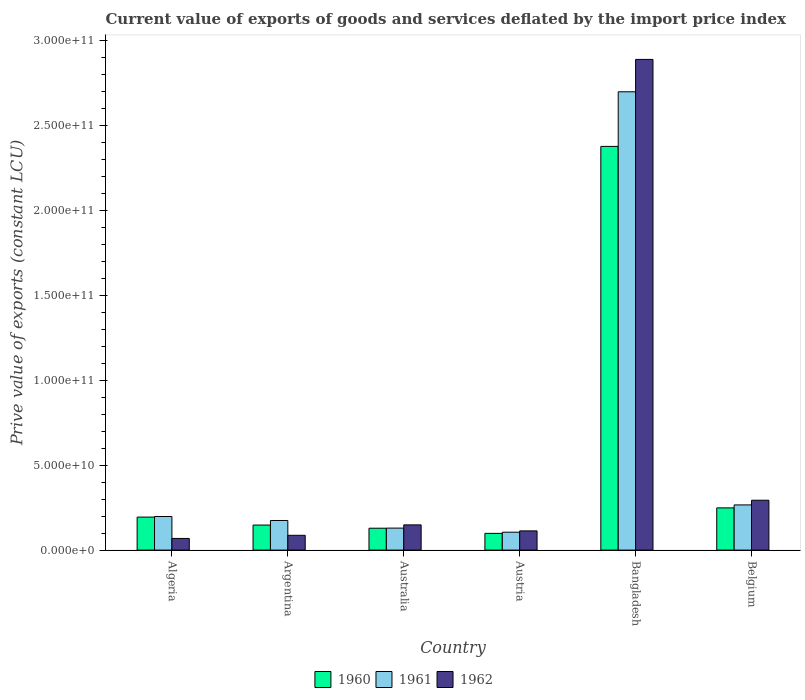How many bars are there on the 6th tick from the right?
Your response must be concise. 3. What is the prive value of exports in 1960 in Austria?
Offer a terse response. 9.86e+09. Across all countries, what is the maximum prive value of exports in 1961?
Provide a short and direct response. 2.70e+11. Across all countries, what is the minimum prive value of exports in 1961?
Offer a very short reply. 1.06e+1. In which country was the prive value of exports in 1960 minimum?
Offer a very short reply. Austria. What is the total prive value of exports in 1962 in the graph?
Your response must be concise. 3.60e+11. What is the difference between the prive value of exports in 1961 in Australia and that in Belgium?
Your answer should be compact. -1.37e+1. What is the difference between the prive value of exports in 1962 in Argentina and the prive value of exports in 1960 in Australia?
Make the answer very short. -4.17e+09. What is the average prive value of exports in 1962 per country?
Your answer should be very brief. 6.00e+1. What is the difference between the prive value of exports of/in 1962 and prive value of exports of/in 1961 in Belgium?
Ensure brevity in your answer.  2.76e+09. In how many countries, is the prive value of exports in 1960 greater than 180000000000 LCU?
Provide a short and direct response. 1. What is the ratio of the prive value of exports in 1961 in Algeria to that in Australia?
Your answer should be compact. 1.53. Is the prive value of exports in 1960 in Algeria less than that in Belgium?
Keep it short and to the point. Yes. What is the difference between the highest and the second highest prive value of exports in 1960?
Provide a succinct answer. 2.13e+11. What is the difference between the highest and the lowest prive value of exports in 1961?
Keep it short and to the point. 2.59e+11. Is the sum of the prive value of exports in 1960 in Algeria and Austria greater than the maximum prive value of exports in 1962 across all countries?
Make the answer very short. No. What does the 3rd bar from the left in Belgium represents?
Make the answer very short. 1962. What does the 1st bar from the right in Belgium represents?
Your answer should be very brief. 1962. Is it the case that in every country, the sum of the prive value of exports in 1962 and prive value of exports in 1961 is greater than the prive value of exports in 1960?
Your answer should be compact. Yes. How many bars are there?
Ensure brevity in your answer.  18. Are the values on the major ticks of Y-axis written in scientific E-notation?
Give a very brief answer. Yes. How are the legend labels stacked?
Provide a succinct answer. Horizontal. What is the title of the graph?
Provide a short and direct response. Current value of exports of goods and services deflated by the import price index. What is the label or title of the Y-axis?
Keep it short and to the point. Prive value of exports (constant LCU). What is the Prive value of exports (constant LCU) of 1960 in Algeria?
Keep it short and to the point. 1.94e+1. What is the Prive value of exports (constant LCU) in 1961 in Algeria?
Offer a terse response. 1.98e+1. What is the Prive value of exports (constant LCU) of 1962 in Algeria?
Offer a terse response. 6.86e+09. What is the Prive value of exports (constant LCU) in 1960 in Argentina?
Give a very brief answer. 1.48e+1. What is the Prive value of exports (constant LCU) in 1961 in Argentina?
Your response must be concise. 1.74e+1. What is the Prive value of exports (constant LCU) of 1962 in Argentina?
Provide a succinct answer. 8.72e+09. What is the Prive value of exports (constant LCU) of 1960 in Australia?
Ensure brevity in your answer.  1.29e+1. What is the Prive value of exports (constant LCU) of 1961 in Australia?
Your answer should be compact. 1.30e+1. What is the Prive value of exports (constant LCU) of 1962 in Australia?
Provide a short and direct response. 1.49e+1. What is the Prive value of exports (constant LCU) in 1960 in Austria?
Keep it short and to the point. 9.86e+09. What is the Prive value of exports (constant LCU) of 1961 in Austria?
Provide a short and direct response. 1.06e+1. What is the Prive value of exports (constant LCU) of 1962 in Austria?
Keep it short and to the point. 1.13e+1. What is the Prive value of exports (constant LCU) of 1960 in Bangladesh?
Offer a terse response. 2.38e+11. What is the Prive value of exports (constant LCU) of 1961 in Bangladesh?
Provide a short and direct response. 2.70e+11. What is the Prive value of exports (constant LCU) in 1962 in Bangladesh?
Offer a very short reply. 2.89e+11. What is the Prive value of exports (constant LCU) of 1960 in Belgium?
Give a very brief answer. 2.49e+1. What is the Prive value of exports (constant LCU) of 1961 in Belgium?
Give a very brief answer. 2.66e+1. What is the Prive value of exports (constant LCU) in 1962 in Belgium?
Your response must be concise. 2.94e+1. Across all countries, what is the maximum Prive value of exports (constant LCU) of 1960?
Your answer should be very brief. 2.38e+11. Across all countries, what is the maximum Prive value of exports (constant LCU) of 1961?
Your answer should be very brief. 2.70e+11. Across all countries, what is the maximum Prive value of exports (constant LCU) of 1962?
Your answer should be compact. 2.89e+11. Across all countries, what is the minimum Prive value of exports (constant LCU) of 1960?
Give a very brief answer. 9.86e+09. Across all countries, what is the minimum Prive value of exports (constant LCU) of 1961?
Offer a terse response. 1.06e+1. Across all countries, what is the minimum Prive value of exports (constant LCU) of 1962?
Your answer should be compact. 6.86e+09. What is the total Prive value of exports (constant LCU) in 1960 in the graph?
Ensure brevity in your answer.  3.20e+11. What is the total Prive value of exports (constant LCU) in 1961 in the graph?
Keep it short and to the point. 3.57e+11. What is the total Prive value of exports (constant LCU) of 1962 in the graph?
Keep it short and to the point. 3.60e+11. What is the difference between the Prive value of exports (constant LCU) in 1960 in Algeria and that in Argentina?
Your response must be concise. 4.69e+09. What is the difference between the Prive value of exports (constant LCU) in 1961 in Algeria and that in Argentina?
Offer a very short reply. 2.35e+09. What is the difference between the Prive value of exports (constant LCU) in 1962 in Algeria and that in Argentina?
Make the answer very short. -1.85e+09. What is the difference between the Prive value of exports (constant LCU) in 1960 in Algeria and that in Australia?
Your response must be concise. 6.55e+09. What is the difference between the Prive value of exports (constant LCU) of 1961 in Algeria and that in Australia?
Keep it short and to the point. 6.83e+09. What is the difference between the Prive value of exports (constant LCU) in 1962 in Algeria and that in Australia?
Offer a very short reply. -7.99e+09. What is the difference between the Prive value of exports (constant LCU) of 1960 in Algeria and that in Austria?
Make the answer very short. 9.59e+09. What is the difference between the Prive value of exports (constant LCU) in 1961 in Algeria and that in Austria?
Your answer should be compact. 9.23e+09. What is the difference between the Prive value of exports (constant LCU) in 1962 in Algeria and that in Austria?
Offer a very short reply. -4.45e+09. What is the difference between the Prive value of exports (constant LCU) in 1960 in Algeria and that in Bangladesh?
Your answer should be compact. -2.18e+11. What is the difference between the Prive value of exports (constant LCU) of 1961 in Algeria and that in Bangladesh?
Provide a succinct answer. -2.50e+11. What is the difference between the Prive value of exports (constant LCU) of 1962 in Algeria and that in Bangladesh?
Give a very brief answer. -2.82e+11. What is the difference between the Prive value of exports (constant LCU) in 1960 in Algeria and that in Belgium?
Ensure brevity in your answer.  -5.42e+09. What is the difference between the Prive value of exports (constant LCU) in 1961 in Algeria and that in Belgium?
Give a very brief answer. -6.83e+09. What is the difference between the Prive value of exports (constant LCU) of 1962 in Algeria and that in Belgium?
Your response must be concise. -2.25e+1. What is the difference between the Prive value of exports (constant LCU) in 1960 in Argentina and that in Australia?
Make the answer very short. 1.87e+09. What is the difference between the Prive value of exports (constant LCU) in 1961 in Argentina and that in Australia?
Give a very brief answer. 4.48e+09. What is the difference between the Prive value of exports (constant LCU) in 1962 in Argentina and that in Australia?
Make the answer very short. -6.14e+09. What is the difference between the Prive value of exports (constant LCU) in 1960 in Argentina and that in Austria?
Your response must be concise. 4.90e+09. What is the difference between the Prive value of exports (constant LCU) of 1961 in Argentina and that in Austria?
Your answer should be compact. 6.89e+09. What is the difference between the Prive value of exports (constant LCU) of 1962 in Argentina and that in Austria?
Keep it short and to the point. -2.60e+09. What is the difference between the Prive value of exports (constant LCU) of 1960 in Argentina and that in Bangladesh?
Offer a terse response. -2.23e+11. What is the difference between the Prive value of exports (constant LCU) in 1961 in Argentina and that in Bangladesh?
Keep it short and to the point. -2.53e+11. What is the difference between the Prive value of exports (constant LCU) in 1962 in Argentina and that in Bangladesh?
Offer a terse response. -2.80e+11. What is the difference between the Prive value of exports (constant LCU) of 1960 in Argentina and that in Belgium?
Keep it short and to the point. -1.01e+1. What is the difference between the Prive value of exports (constant LCU) in 1961 in Argentina and that in Belgium?
Provide a succinct answer. -9.17e+09. What is the difference between the Prive value of exports (constant LCU) in 1962 in Argentina and that in Belgium?
Keep it short and to the point. -2.07e+1. What is the difference between the Prive value of exports (constant LCU) of 1960 in Australia and that in Austria?
Give a very brief answer. 3.04e+09. What is the difference between the Prive value of exports (constant LCU) in 1961 in Australia and that in Austria?
Keep it short and to the point. 2.41e+09. What is the difference between the Prive value of exports (constant LCU) of 1962 in Australia and that in Austria?
Provide a short and direct response. 3.54e+09. What is the difference between the Prive value of exports (constant LCU) of 1960 in Australia and that in Bangladesh?
Offer a very short reply. -2.25e+11. What is the difference between the Prive value of exports (constant LCU) in 1961 in Australia and that in Bangladesh?
Keep it short and to the point. -2.57e+11. What is the difference between the Prive value of exports (constant LCU) of 1962 in Australia and that in Bangladesh?
Offer a terse response. -2.74e+11. What is the difference between the Prive value of exports (constant LCU) in 1960 in Australia and that in Belgium?
Your response must be concise. -1.20e+1. What is the difference between the Prive value of exports (constant LCU) of 1961 in Australia and that in Belgium?
Your answer should be very brief. -1.37e+1. What is the difference between the Prive value of exports (constant LCU) of 1962 in Australia and that in Belgium?
Provide a succinct answer. -1.45e+1. What is the difference between the Prive value of exports (constant LCU) of 1960 in Austria and that in Bangladesh?
Give a very brief answer. -2.28e+11. What is the difference between the Prive value of exports (constant LCU) in 1961 in Austria and that in Bangladesh?
Offer a very short reply. -2.59e+11. What is the difference between the Prive value of exports (constant LCU) of 1962 in Austria and that in Bangladesh?
Your answer should be compact. -2.78e+11. What is the difference between the Prive value of exports (constant LCU) in 1960 in Austria and that in Belgium?
Give a very brief answer. -1.50e+1. What is the difference between the Prive value of exports (constant LCU) in 1961 in Austria and that in Belgium?
Give a very brief answer. -1.61e+1. What is the difference between the Prive value of exports (constant LCU) in 1962 in Austria and that in Belgium?
Your answer should be very brief. -1.81e+1. What is the difference between the Prive value of exports (constant LCU) of 1960 in Bangladesh and that in Belgium?
Give a very brief answer. 2.13e+11. What is the difference between the Prive value of exports (constant LCU) of 1961 in Bangladesh and that in Belgium?
Offer a terse response. 2.43e+11. What is the difference between the Prive value of exports (constant LCU) in 1962 in Bangladesh and that in Belgium?
Your response must be concise. 2.60e+11. What is the difference between the Prive value of exports (constant LCU) of 1960 in Algeria and the Prive value of exports (constant LCU) of 1961 in Argentina?
Give a very brief answer. 2.01e+09. What is the difference between the Prive value of exports (constant LCU) of 1960 in Algeria and the Prive value of exports (constant LCU) of 1962 in Argentina?
Provide a succinct answer. 1.07e+1. What is the difference between the Prive value of exports (constant LCU) of 1961 in Algeria and the Prive value of exports (constant LCU) of 1962 in Argentina?
Keep it short and to the point. 1.11e+1. What is the difference between the Prive value of exports (constant LCU) of 1960 in Algeria and the Prive value of exports (constant LCU) of 1961 in Australia?
Provide a short and direct response. 6.49e+09. What is the difference between the Prive value of exports (constant LCU) in 1960 in Algeria and the Prive value of exports (constant LCU) in 1962 in Australia?
Your answer should be very brief. 4.59e+09. What is the difference between the Prive value of exports (constant LCU) of 1961 in Algeria and the Prive value of exports (constant LCU) of 1962 in Australia?
Provide a short and direct response. 4.93e+09. What is the difference between the Prive value of exports (constant LCU) in 1960 in Algeria and the Prive value of exports (constant LCU) in 1961 in Austria?
Your response must be concise. 8.89e+09. What is the difference between the Prive value of exports (constant LCU) in 1960 in Algeria and the Prive value of exports (constant LCU) in 1962 in Austria?
Keep it short and to the point. 8.13e+09. What is the difference between the Prive value of exports (constant LCU) in 1961 in Algeria and the Prive value of exports (constant LCU) in 1962 in Austria?
Keep it short and to the point. 8.47e+09. What is the difference between the Prive value of exports (constant LCU) in 1960 in Algeria and the Prive value of exports (constant LCU) in 1961 in Bangladesh?
Your response must be concise. -2.51e+11. What is the difference between the Prive value of exports (constant LCU) in 1960 in Algeria and the Prive value of exports (constant LCU) in 1962 in Bangladesh?
Make the answer very short. -2.70e+11. What is the difference between the Prive value of exports (constant LCU) of 1961 in Algeria and the Prive value of exports (constant LCU) of 1962 in Bangladesh?
Offer a very short reply. -2.69e+11. What is the difference between the Prive value of exports (constant LCU) of 1960 in Algeria and the Prive value of exports (constant LCU) of 1961 in Belgium?
Your response must be concise. -7.17e+09. What is the difference between the Prive value of exports (constant LCU) of 1960 in Algeria and the Prive value of exports (constant LCU) of 1962 in Belgium?
Ensure brevity in your answer.  -9.93e+09. What is the difference between the Prive value of exports (constant LCU) in 1961 in Algeria and the Prive value of exports (constant LCU) in 1962 in Belgium?
Offer a very short reply. -9.59e+09. What is the difference between the Prive value of exports (constant LCU) in 1960 in Argentina and the Prive value of exports (constant LCU) in 1961 in Australia?
Offer a terse response. 1.80e+09. What is the difference between the Prive value of exports (constant LCU) of 1960 in Argentina and the Prive value of exports (constant LCU) of 1962 in Australia?
Your response must be concise. -9.94e+07. What is the difference between the Prive value of exports (constant LCU) in 1961 in Argentina and the Prive value of exports (constant LCU) in 1962 in Australia?
Your answer should be compact. 2.58e+09. What is the difference between the Prive value of exports (constant LCU) in 1960 in Argentina and the Prive value of exports (constant LCU) in 1961 in Austria?
Keep it short and to the point. 4.21e+09. What is the difference between the Prive value of exports (constant LCU) of 1960 in Argentina and the Prive value of exports (constant LCU) of 1962 in Austria?
Make the answer very short. 3.44e+09. What is the difference between the Prive value of exports (constant LCU) of 1961 in Argentina and the Prive value of exports (constant LCU) of 1962 in Austria?
Keep it short and to the point. 6.12e+09. What is the difference between the Prive value of exports (constant LCU) in 1960 in Argentina and the Prive value of exports (constant LCU) in 1961 in Bangladesh?
Give a very brief answer. -2.55e+11. What is the difference between the Prive value of exports (constant LCU) in 1960 in Argentina and the Prive value of exports (constant LCU) in 1962 in Bangladesh?
Your response must be concise. -2.74e+11. What is the difference between the Prive value of exports (constant LCU) of 1961 in Argentina and the Prive value of exports (constant LCU) of 1962 in Bangladesh?
Provide a short and direct response. -2.72e+11. What is the difference between the Prive value of exports (constant LCU) in 1960 in Argentina and the Prive value of exports (constant LCU) in 1961 in Belgium?
Make the answer very short. -1.19e+1. What is the difference between the Prive value of exports (constant LCU) of 1960 in Argentina and the Prive value of exports (constant LCU) of 1962 in Belgium?
Give a very brief answer. -1.46e+1. What is the difference between the Prive value of exports (constant LCU) in 1961 in Argentina and the Prive value of exports (constant LCU) in 1962 in Belgium?
Keep it short and to the point. -1.19e+1. What is the difference between the Prive value of exports (constant LCU) in 1960 in Australia and the Prive value of exports (constant LCU) in 1961 in Austria?
Offer a very short reply. 2.34e+09. What is the difference between the Prive value of exports (constant LCU) of 1960 in Australia and the Prive value of exports (constant LCU) of 1962 in Austria?
Keep it short and to the point. 1.57e+09. What is the difference between the Prive value of exports (constant LCU) in 1961 in Australia and the Prive value of exports (constant LCU) in 1962 in Austria?
Provide a short and direct response. 1.64e+09. What is the difference between the Prive value of exports (constant LCU) in 1960 in Australia and the Prive value of exports (constant LCU) in 1961 in Bangladesh?
Give a very brief answer. -2.57e+11. What is the difference between the Prive value of exports (constant LCU) of 1960 in Australia and the Prive value of exports (constant LCU) of 1962 in Bangladesh?
Offer a terse response. -2.76e+11. What is the difference between the Prive value of exports (constant LCU) in 1961 in Australia and the Prive value of exports (constant LCU) in 1962 in Bangladesh?
Keep it short and to the point. -2.76e+11. What is the difference between the Prive value of exports (constant LCU) in 1960 in Australia and the Prive value of exports (constant LCU) in 1961 in Belgium?
Ensure brevity in your answer.  -1.37e+1. What is the difference between the Prive value of exports (constant LCU) in 1960 in Australia and the Prive value of exports (constant LCU) in 1962 in Belgium?
Provide a succinct answer. -1.65e+1. What is the difference between the Prive value of exports (constant LCU) of 1961 in Australia and the Prive value of exports (constant LCU) of 1962 in Belgium?
Give a very brief answer. -1.64e+1. What is the difference between the Prive value of exports (constant LCU) of 1960 in Austria and the Prive value of exports (constant LCU) of 1961 in Bangladesh?
Your response must be concise. -2.60e+11. What is the difference between the Prive value of exports (constant LCU) of 1960 in Austria and the Prive value of exports (constant LCU) of 1962 in Bangladesh?
Offer a terse response. -2.79e+11. What is the difference between the Prive value of exports (constant LCU) in 1961 in Austria and the Prive value of exports (constant LCU) in 1962 in Bangladesh?
Offer a terse response. -2.78e+11. What is the difference between the Prive value of exports (constant LCU) of 1960 in Austria and the Prive value of exports (constant LCU) of 1961 in Belgium?
Your response must be concise. -1.68e+1. What is the difference between the Prive value of exports (constant LCU) of 1960 in Austria and the Prive value of exports (constant LCU) of 1962 in Belgium?
Your answer should be compact. -1.95e+1. What is the difference between the Prive value of exports (constant LCU) in 1961 in Austria and the Prive value of exports (constant LCU) in 1962 in Belgium?
Give a very brief answer. -1.88e+1. What is the difference between the Prive value of exports (constant LCU) in 1960 in Bangladesh and the Prive value of exports (constant LCU) in 1961 in Belgium?
Your response must be concise. 2.11e+11. What is the difference between the Prive value of exports (constant LCU) in 1960 in Bangladesh and the Prive value of exports (constant LCU) in 1962 in Belgium?
Offer a terse response. 2.08e+11. What is the difference between the Prive value of exports (constant LCU) of 1961 in Bangladesh and the Prive value of exports (constant LCU) of 1962 in Belgium?
Your answer should be compact. 2.41e+11. What is the average Prive value of exports (constant LCU) in 1960 per country?
Ensure brevity in your answer.  5.33e+1. What is the average Prive value of exports (constant LCU) of 1961 per country?
Provide a short and direct response. 5.95e+1. What is the average Prive value of exports (constant LCU) in 1962 per country?
Provide a short and direct response. 6.00e+1. What is the difference between the Prive value of exports (constant LCU) of 1960 and Prive value of exports (constant LCU) of 1961 in Algeria?
Your answer should be very brief. -3.40e+08. What is the difference between the Prive value of exports (constant LCU) of 1960 and Prive value of exports (constant LCU) of 1962 in Algeria?
Make the answer very short. 1.26e+1. What is the difference between the Prive value of exports (constant LCU) in 1961 and Prive value of exports (constant LCU) in 1962 in Algeria?
Offer a terse response. 1.29e+1. What is the difference between the Prive value of exports (constant LCU) in 1960 and Prive value of exports (constant LCU) in 1961 in Argentina?
Offer a terse response. -2.68e+09. What is the difference between the Prive value of exports (constant LCU) of 1960 and Prive value of exports (constant LCU) of 1962 in Argentina?
Provide a succinct answer. 6.04e+09. What is the difference between the Prive value of exports (constant LCU) of 1961 and Prive value of exports (constant LCU) of 1962 in Argentina?
Provide a succinct answer. 8.72e+09. What is the difference between the Prive value of exports (constant LCU) in 1960 and Prive value of exports (constant LCU) in 1961 in Australia?
Provide a succinct answer. -6.58e+07. What is the difference between the Prive value of exports (constant LCU) of 1960 and Prive value of exports (constant LCU) of 1962 in Australia?
Offer a very short reply. -1.96e+09. What is the difference between the Prive value of exports (constant LCU) in 1961 and Prive value of exports (constant LCU) in 1962 in Australia?
Ensure brevity in your answer.  -1.90e+09. What is the difference between the Prive value of exports (constant LCU) of 1960 and Prive value of exports (constant LCU) of 1961 in Austria?
Offer a terse response. -6.95e+08. What is the difference between the Prive value of exports (constant LCU) in 1960 and Prive value of exports (constant LCU) in 1962 in Austria?
Provide a succinct answer. -1.46e+09. What is the difference between the Prive value of exports (constant LCU) of 1961 and Prive value of exports (constant LCU) of 1962 in Austria?
Provide a succinct answer. -7.67e+08. What is the difference between the Prive value of exports (constant LCU) in 1960 and Prive value of exports (constant LCU) in 1961 in Bangladesh?
Your answer should be compact. -3.22e+1. What is the difference between the Prive value of exports (constant LCU) in 1960 and Prive value of exports (constant LCU) in 1962 in Bangladesh?
Ensure brevity in your answer.  -5.12e+1. What is the difference between the Prive value of exports (constant LCU) of 1961 and Prive value of exports (constant LCU) of 1962 in Bangladesh?
Ensure brevity in your answer.  -1.91e+1. What is the difference between the Prive value of exports (constant LCU) in 1960 and Prive value of exports (constant LCU) in 1961 in Belgium?
Provide a succinct answer. -1.74e+09. What is the difference between the Prive value of exports (constant LCU) of 1960 and Prive value of exports (constant LCU) of 1962 in Belgium?
Provide a succinct answer. -4.50e+09. What is the difference between the Prive value of exports (constant LCU) of 1961 and Prive value of exports (constant LCU) of 1962 in Belgium?
Provide a succinct answer. -2.76e+09. What is the ratio of the Prive value of exports (constant LCU) in 1960 in Algeria to that in Argentina?
Offer a very short reply. 1.32. What is the ratio of the Prive value of exports (constant LCU) in 1961 in Algeria to that in Argentina?
Ensure brevity in your answer.  1.13. What is the ratio of the Prive value of exports (constant LCU) in 1962 in Algeria to that in Argentina?
Keep it short and to the point. 0.79. What is the ratio of the Prive value of exports (constant LCU) in 1960 in Algeria to that in Australia?
Offer a terse response. 1.51. What is the ratio of the Prive value of exports (constant LCU) in 1961 in Algeria to that in Australia?
Make the answer very short. 1.53. What is the ratio of the Prive value of exports (constant LCU) in 1962 in Algeria to that in Australia?
Your answer should be compact. 0.46. What is the ratio of the Prive value of exports (constant LCU) in 1960 in Algeria to that in Austria?
Give a very brief answer. 1.97. What is the ratio of the Prive value of exports (constant LCU) in 1961 in Algeria to that in Austria?
Offer a very short reply. 1.88. What is the ratio of the Prive value of exports (constant LCU) in 1962 in Algeria to that in Austria?
Give a very brief answer. 0.61. What is the ratio of the Prive value of exports (constant LCU) in 1960 in Algeria to that in Bangladesh?
Your answer should be compact. 0.08. What is the ratio of the Prive value of exports (constant LCU) of 1961 in Algeria to that in Bangladesh?
Ensure brevity in your answer.  0.07. What is the ratio of the Prive value of exports (constant LCU) of 1962 in Algeria to that in Bangladesh?
Your answer should be compact. 0.02. What is the ratio of the Prive value of exports (constant LCU) in 1960 in Algeria to that in Belgium?
Make the answer very short. 0.78. What is the ratio of the Prive value of exports (constant LCU) of 1961 in Algeria to that in Belgium?
Offer a very short reply. 0.74. What is the ratio of the Prive value of exports (constant LCU) of 1962 in Algeria to that in Belgium?
Offer a terse response. 0.23. What is the ratio of the Prive value of exports (constant LCU) in 1960 in Argentina to that in Australia?
Provide a short and direct response. 1.14. What is the ratio of the Prive value of exports (constant LCU) of 1961 in Argentina to that in Australia?
Ensure brevity in your answer.  1.35. What is the ratio of the Prive value of exports (constant LCU) of 1962 in Argentina to that in Australia?
Make the answer very short. 0.59. What is the ratio of the Prive value of exports (constant LCU) of 1960 in Argentina to that in Austria?
Keep it short and to the point. 1.5. What is the ratio of the Prive value of exports (constant LCU) in 1961 in Argentina to that in Austria?
Your answer should be very brief. 1.65. What is the ratio of the Prive value of exports (constant LCU) in 1962 in Argentina to that in Austria?
Offer a very short reply. 0.77. What is the ratio of the Prive value of exports (constant LCU) in 1960 in Argentina to that in Bangladesh?
Your response must be concise. 0.06. What is the ratio of the Prive value of exports (constant LCU) in 1961 in Argentina to that in Bangladesh?
Your answer should be compact. 0.06. What is the ratio of the Prive value of exports (constant LCU) in 1962 in Argentina to that in Bangladesh?
Offer a very short reply. 0.03. What is the ratio of the Prive value of exports (constant LCU) of 1960 in Argentina to that in Belgium?
Make the answer very short. 0.59. What is the ratio of the Prive value of exports (constant LCU) in 1961 in Argentina to that in Belgium?
Your response must be concise. 0.66. What is the ratio of the Prive value of exports (constant LCU) in 1962 in Argentina to that in Belgium?
Ensure brevity in your answer.  0.3. What is the ratio of the Prive value of exports (constant LCU) of 1960 in Australia to that in Austria?
Your answer should be very brief. 1.31. What is the ratio of the Prive value of exports (constant LCU) in 1961 in Australia to that in Austria?
Your response must be concise. 1.23. What is the ratio of the Prive value of exports (constant LCU) in 1962 in Australia to that in Austria?
Give a very brief answer. 1.31. What is the ratio of the Prive value of exports (constant LCU) in 1960 in Australia to that in Bangladesh?
Provide a succinct answer. 0.05. What is the ratio of the Prive value of exports (constant LCU) of 1961 in Australia to that in Bangladesh?
Your response must be concise. 0.05. What is the ratio of the Prive value of exports (constant LCU) in 1962 in Australia to that in Bangladesh?
Give a very brief answer. 0.05. What is the ratio of the Prive value of exports (constant LCU) in 1960 in Australia to that in Belgium?
Offer a very short reply. 0.52. What is the ratio of the Prive value of exports (constant LCU) in 1961 in Australia to that in Belgium?
Your answer should be very brief. 0.49. What is the ratio of the Prive value of exports (constant LCU) of 1962 in Australia to that in Belgium?
Ensure brevity in your answer.  0.51. What is the ratio of the Prive value of exports (constant LCU) of 1960 in Austria to that in Bangladesh?
Give a very brief answer. 0.04. What is the ratio of the Prive value of exports (constant LCU) in 1961 in Austria to that in Bangladesh?
Ensure brevity in your answer.  0.04. What is the ratio of the Prive value of exports (constant LCU) of 1962 in Austria to that in Bangladesh?
Your answer should be compact. 0.04. What is the ratio of the Prive value of exports (constant LCU) in 1960 in Austria to that in Belgium?
Your answer should be compact. 0.4. What is the ratio of the Prive value of exports (constant LCU) in 1961 in Austria to that in Belgium?
Provide a short and direct response. 0.4. What is the ratio of the Prive value of exports (constant LCU) in 1962 in Austria to that in Belgium?
Your response must be concise. 0.39. What is the ratio of the Prive value of exports (constant LCU) in 1960 in Bangladesh to that in Belgium?
Make the answer very short. 9.56. What is the ratio of the Prive value of exports (constant LCU) in 1961 in Bangladesh to that in Belgium?
Offer a terse response. 10.14. What is the ratio of the Prive value of exports (constant LCU) of 1962 in Bangladesh to that in Belgium?
Offer a very short reply. 9.84. What is the difference between the highest and the second highest Prive value of exports (constant LCU) of 1960?
Ensure brevity in your answer.  2.13e+11. What is the difference between the highest and the second highest Prive value of exports (constant LCU) of 1961?
Your answer should be compact. 2.43e+11. What is the difference between the highest and the second highest Prive value of exports (constant LCU) of 1962?
Your answer should be compact. 2.60e+11. What is the difference between the highest and the lowest Prive value of exports (constant LCU) in 1960?
Offer a terse response. 2.28e+11. What is the difference between the highest and the lowest Prive value of exports (constant LCU) in 1961?
Give a very brief answer. 2.59e+11. What is the difference between the highest and the lowest Prive value of exports (constant LCU) of 1962?
Keep it short and to the point. 2.82e+11. 